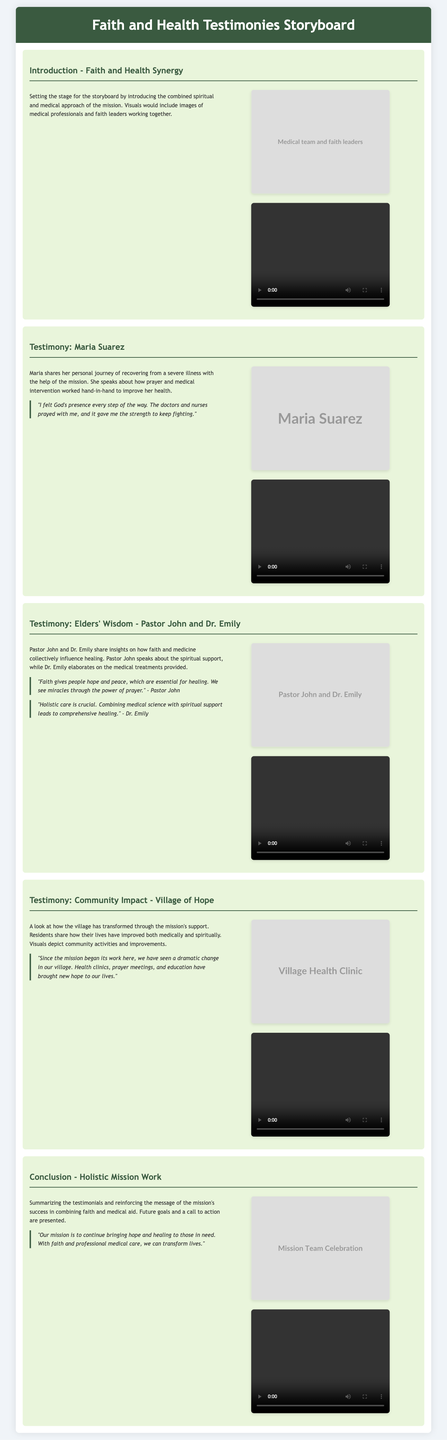what is the title of the storyboard? The title of the storyboard is clearly indicated in the header section.
Answer: Faith and Health Testimonies Storyboard who shares their testimony of recovery from a severe illness? The character providing this testimony is mentioned in the testimony segment of the document.
Answer: Maria Suarez what visual represents the community impact in the village? This visual can be found under the section discussing the transformation seen in the village due to the mission's support.
Answer: A new health clinic with villagers gathering outside who are the two individuals that provide insights on faith and medicine? Their names are highlighted in the testimony section discussing the collective influence on healing.
Answer: Pastor John and Dr. Emily what main theme is discussed in the introduction? The focus of the introduction is stated in relation to the overarching support provided by the mission.
Answer: Combined spiritual and medical approach how does Maria describe her experience with prayer during her illness? This can be found in a quotation within her personal story in the document.
Answer: "I felt God's presence every step of the way." what type of visuals are included throughout the storyboard? These visuals accompany the testimonies and are categorized within the scene structure as a specific element.
Answer: Images and videos how many testimonies are featured in the storyboard? The number of testimonies is indicated through the count of unique segments dedicated to personal stories.
Answer: Four 